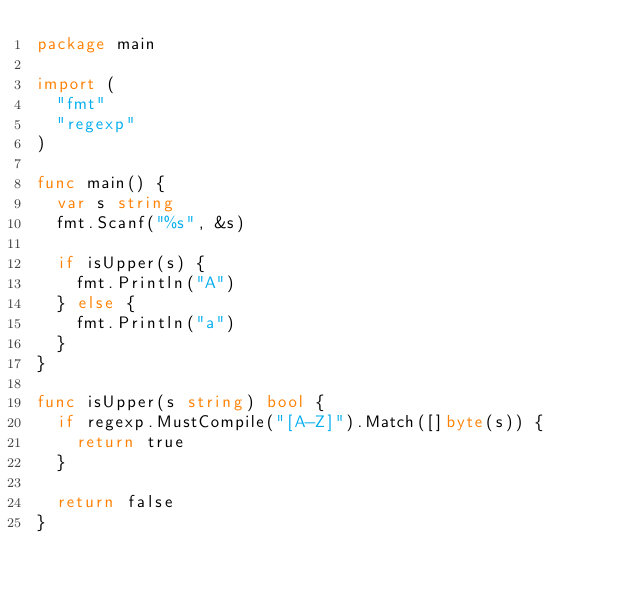Convert code to text. <code><loc_0><loc_0><loc_500><loc_500><_Go_>package main

import (
	"fmt"
	"regexp"
)

func main() {
	var s string
	fmt.Scanf("%s", &s)

	if isUpper(s) {
		fmt.Println("A")
	} else {
		fmt.Println("a")
	}
}

func isUpper(s string) bool {
	if regexp.MustCompile("[A-Z]").Match([]byte(s)) {
		return true
	}

	return false
}
</code> 